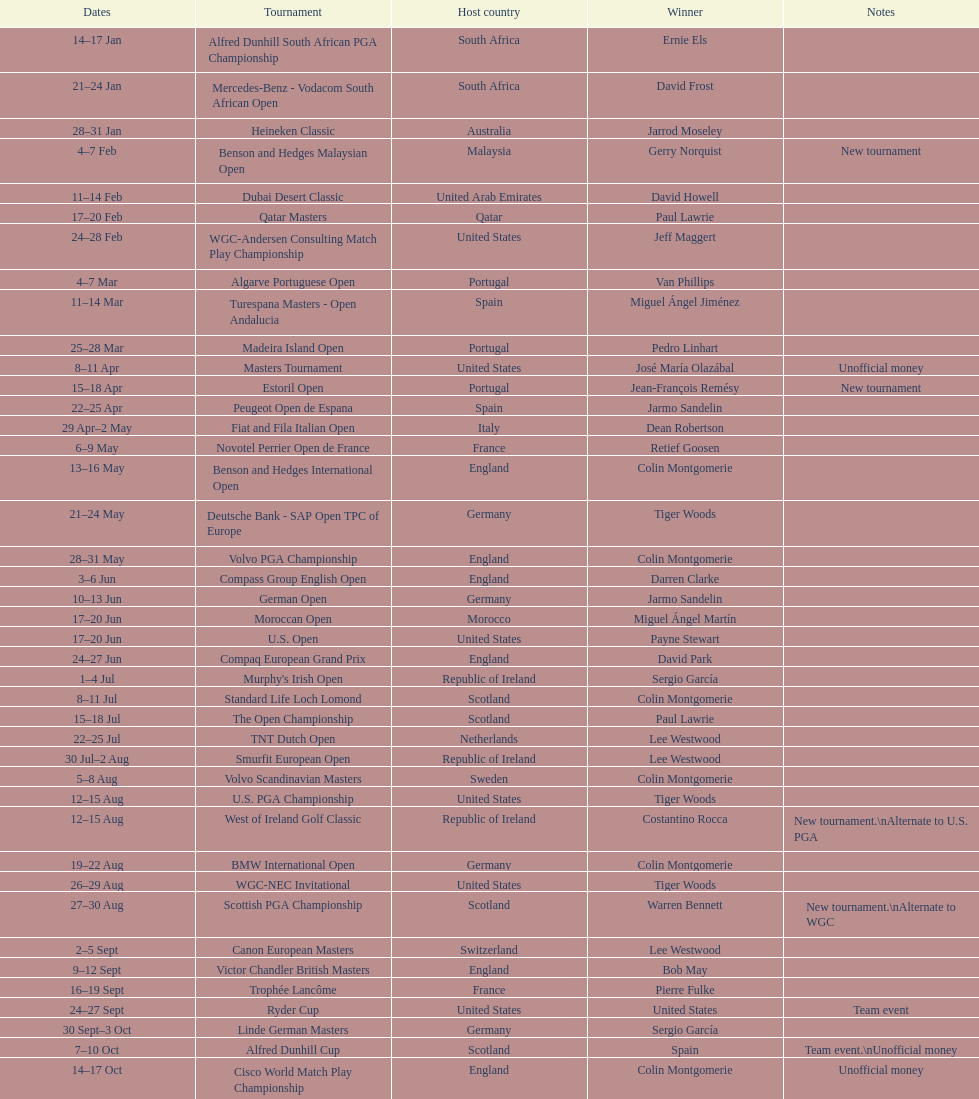How many competitions started before august 15th? 31. 